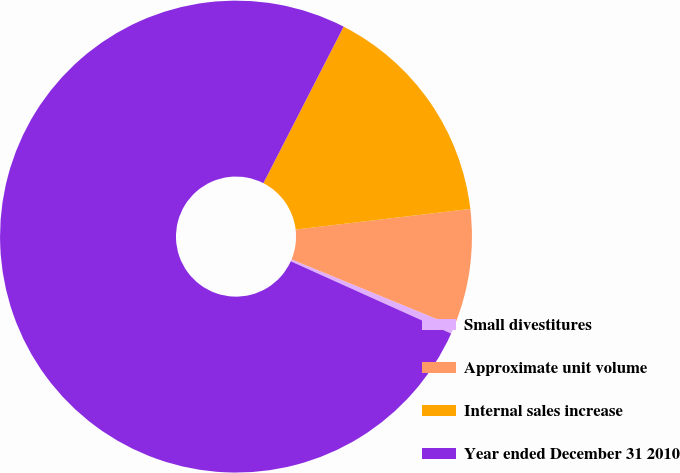Convert chart to OTSL. <chart><loc_0><loc_0><loc_500><loc_500><pie_chart><fcel>Small divestitures<fcel>Approximate unit volume<fcel>Internal sales increase<fcel>Year ended December 31 2010<nl><fcel>0.54%<fcel>8.07%<fcel>15.59%<fcel>75.8%<nl></chart> 